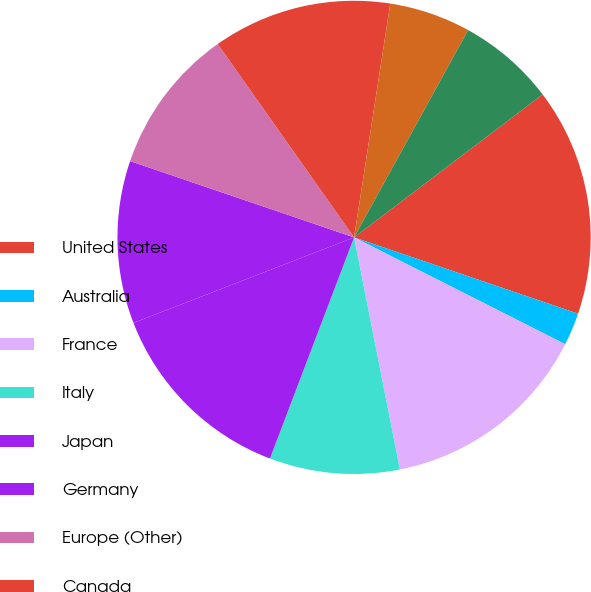Convert chart to OTSL. <chart><loc_0><loc_0><loc_500><loc_500><pie_chart><fcel>United States<fcel>Australia<fcel>France<fcel>Italy<fcel>Japan<fcel>Germany<fcel>Europe (Other)<fcel>Canada<fcel>Spain<fcel>Mexico<nl><fcel>15.55%<fcel>2.23%<fcel>14.44%<fcel>8.89%<fcel>13.33%<fcel>11.11%<fcel>10.0%<fcel>12.22%<fcel>5.56%<fcel>6.67%<nl></chart> 